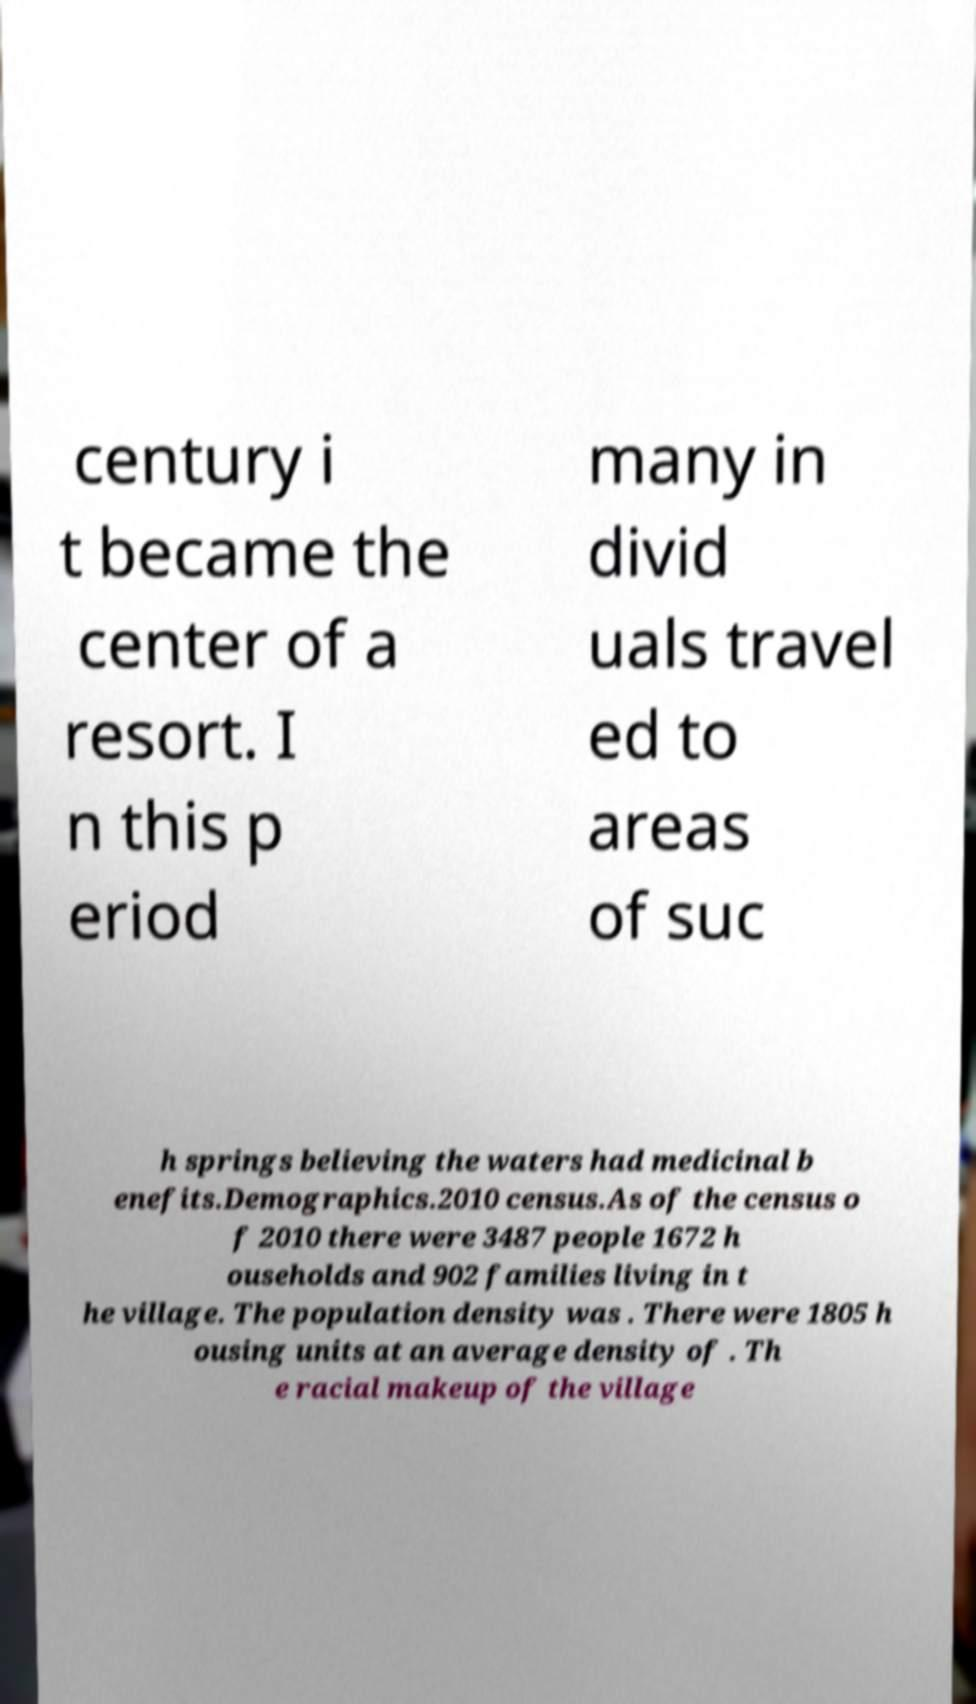I need the written content from this picture converted into text. Can you do that? century i t became the center of a resort. I n this p eriod many in divid uals travel ed to areas of suc h springs believing the waters had medicinal b enefits.Demographics.2010 census.As of the census o f 2010 there were 3487 people 1672 h ouseholds and 902 families living in t he village. The population density was . There were 1805 h ousing units at an average density of . Th e racial makeup of the village 